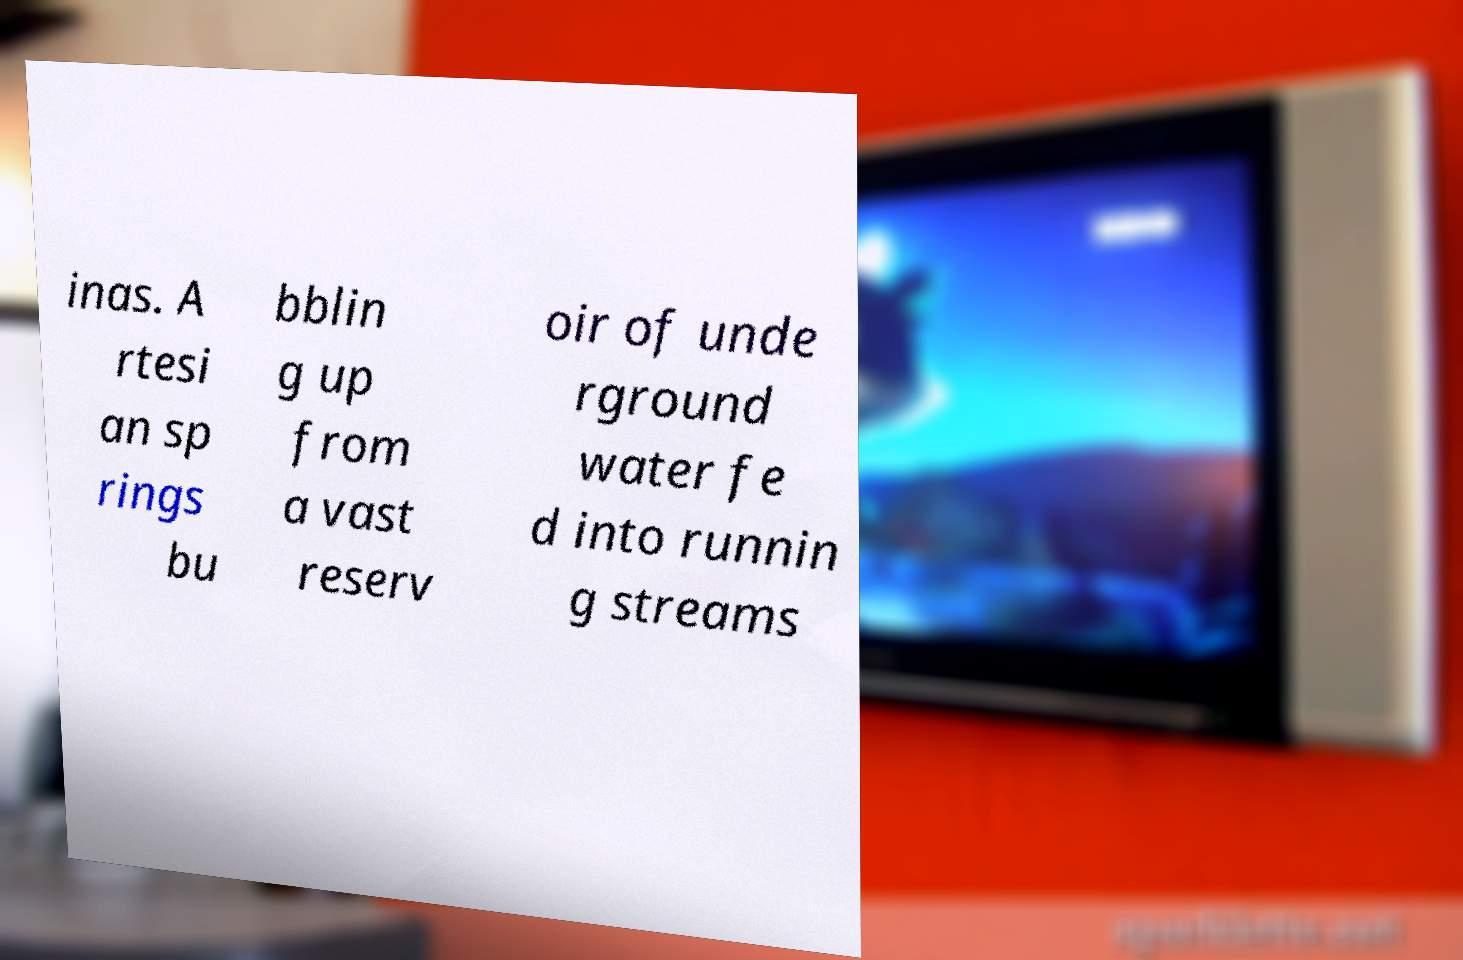What messages or text are displayed in this image? I need them in a readable, typed format. inas. A rtesi an sp rings bu bblin g up from a vast reserv oir of unde rground water fe d into runnin g streams 